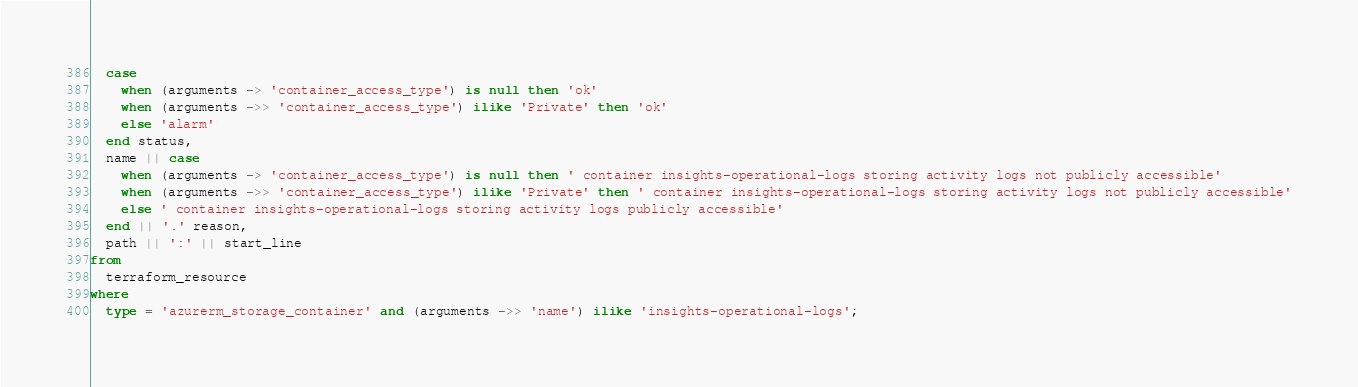Convert code to text. <code><loc_0><loc_0><loc_500><loc_500><_SQL_>  case
    when (arguments -> 'container_access_type') is null then 'ok'
    when (arguments ->> 'container_access_type') ilike 'Private' then 'ok'
    else 'alarm'
  end status,
  name || case
    when (arguments -> 'container_access_type') is null then ' container insights-operational-logs storing activity logs not publicly accessible'
    when (arguments ->> 'container_access_type') ilike 'Private' then ' container insights-operational-logs storing activity logs not publicly accessible'
    else ' container insights-operational-logs storing activity logs publicly accessible'
  end || '.' reason,
  path || ':' || start_line
from
  terraform_resource
where
  type = 'azurerm_storage_container' and (arguments ->> 'name') ilike 'insights-operational-logs';</code> 